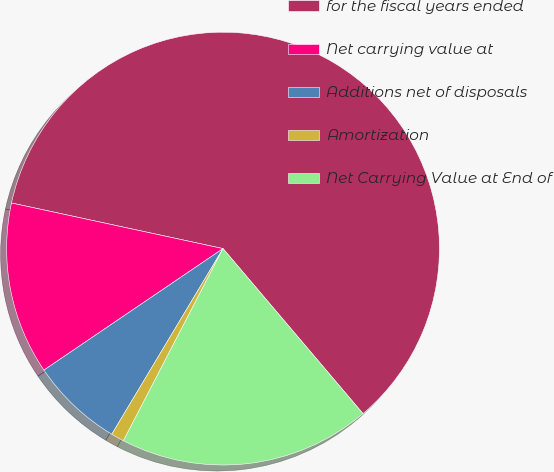<chart> <loc_0><loc_0><loc_500><loc_500><pie_chart><fcel>for the fiscal years ended<fcel>Net carrying value at<fcel>Additions net of disposals<fcel>Amortization<fcel>Net Carrying Value at End of<nl><fcel>60.43%<fcel>12.87%<fcel>6.92%<fcel>0.98%<fcel>18.81%<nl></chart> 